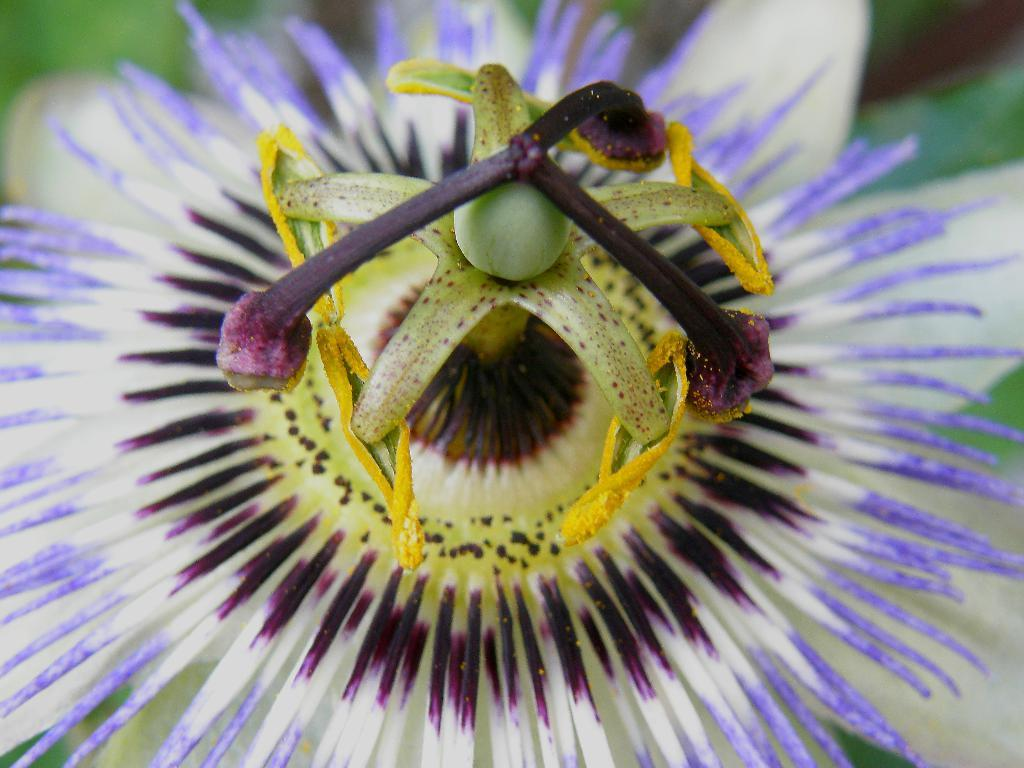What is the main subject of the image? The main subject of the image is a flower. Can you describe the colors of the flower? The flower has purple and white colors. What is unique about the petals of the flower? The flower has sharp petals. How does the boy interact with the flower in the image? There is no boy present in the image; it only features a flower. What type of monkey can be seen climbing the flower in the image? There is no monkey present in the image; it only features a flower. 